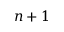<formula> <loc_0><loc_0><loc_500><loc_500>n + 1</formula> 